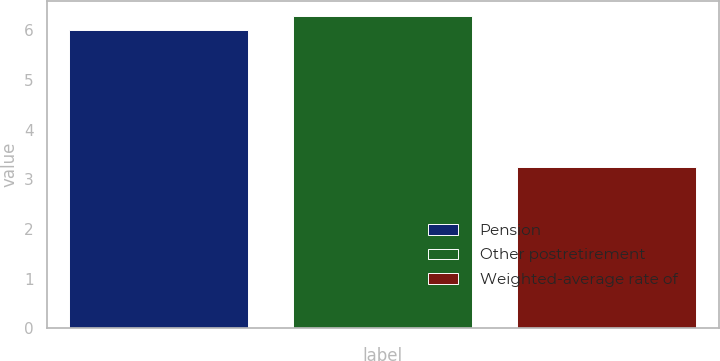Convert chart to OTSL. <chart><loc_0><loc_0><loc_500><loc_500><bar_chart><fcel>Pension<fcel>Other postretirement<fcel>Weighted-average rate of<nl><fcel>6<fcel>6.28<fcel>3.25<nl></chart> 